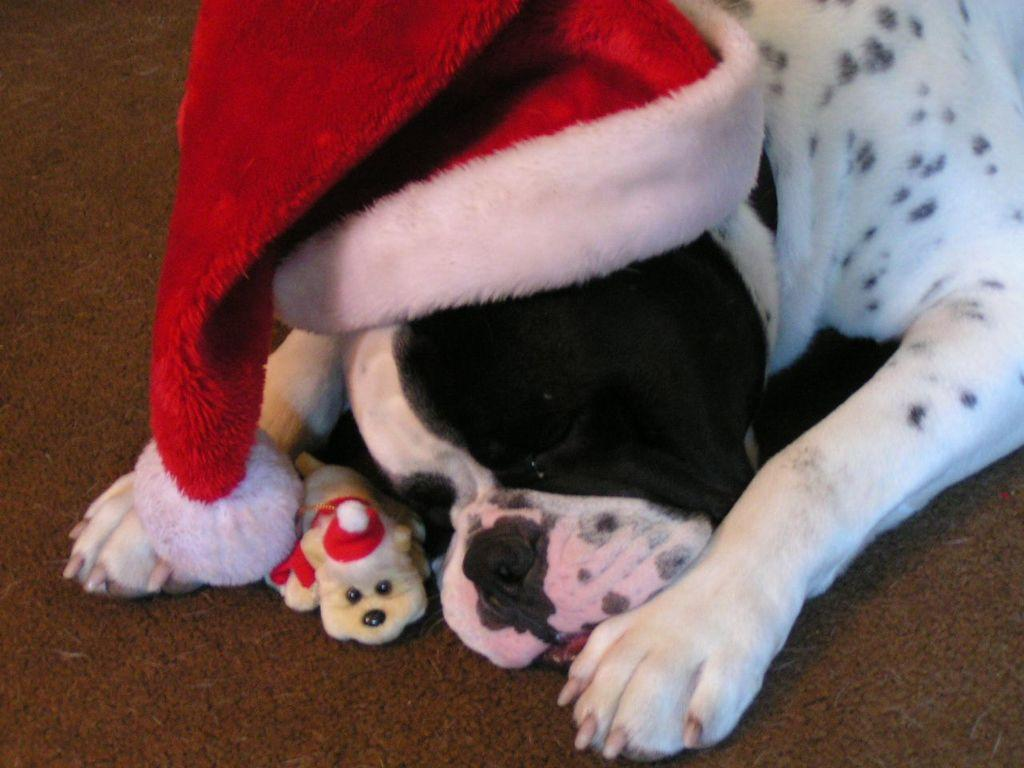What type of animal is in the image? There is a dog in the image. What is the dog wearing? The dog is wearing a Christmas hat. What can be seen on the floor in the image? There is a toy on the floor in the image. What type of territory does the dog claim in the image? There is no indication of the dog claiming any territory in the image. 